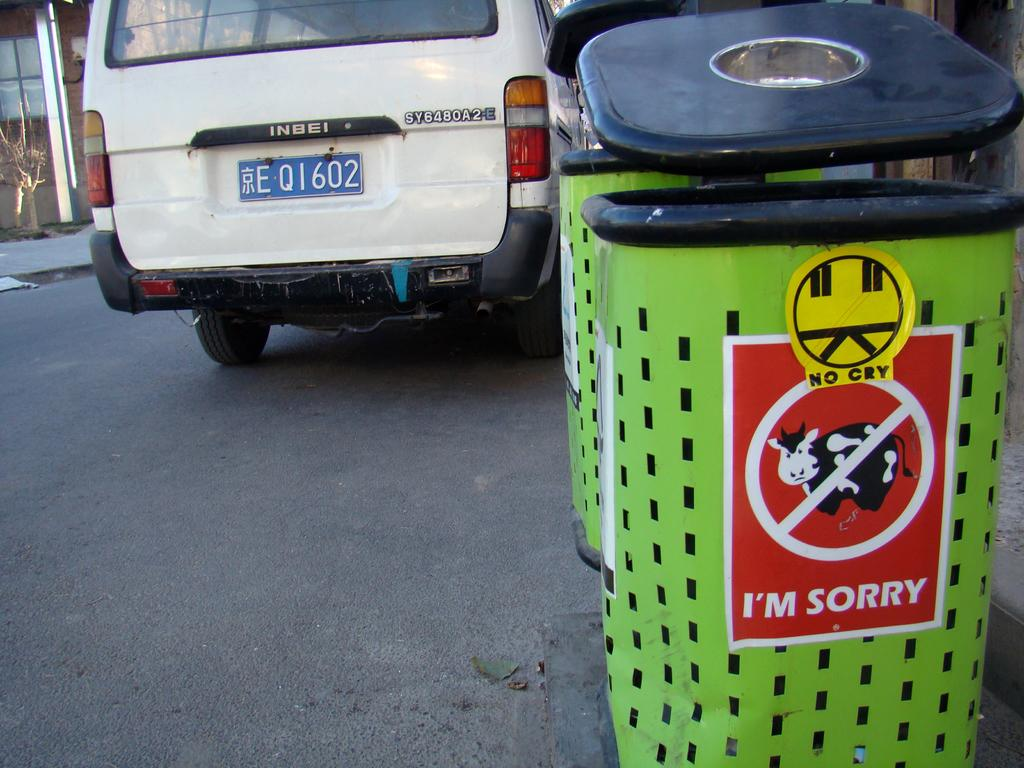What type of containers are present in the image? There are waste bins in the image. Is there any additional information about the waste bins? Yes, there is a poster on one of the bins. What else can be seen in the image besides the waste bins? There is a vehicle on the road, a building with a window in the background, and a tree in the image. What type of prison can be seen in the image? There is no prison present in the image. What type of ring is visible on the vehicle in the image? There is no ring visible on the vehicle in the image. 